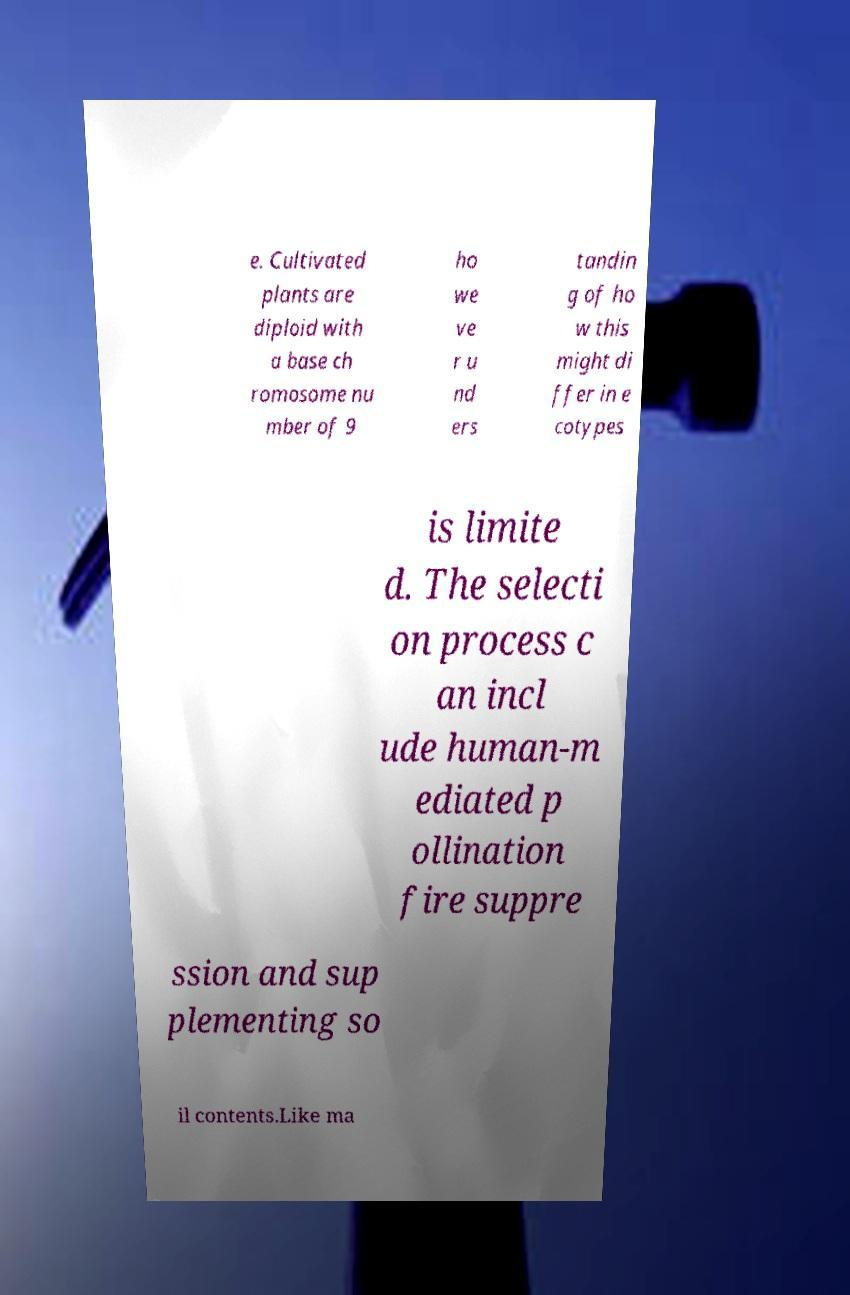I need the written content from this picture converted into text. Can you do that? e. Cultivated plants are diploid with a base ch romosome nu mber of 9 ho we ve r u nd ers tandin g of ho w this might di ffer in e cotypes is limite d. The selecti on process c an incl ude human-m ediated p ollination fire suppre ssion and sup plementing so il contents.Like ma 